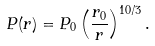Convert formula to latex. <formula><loc_0><loc_0><loc_500><loc_500>P ( r ) = P _ { 0 } \left ( \frac { r _ { 0 } } { r } \right ) ^ { 1 0 / 3 } .</formula> 